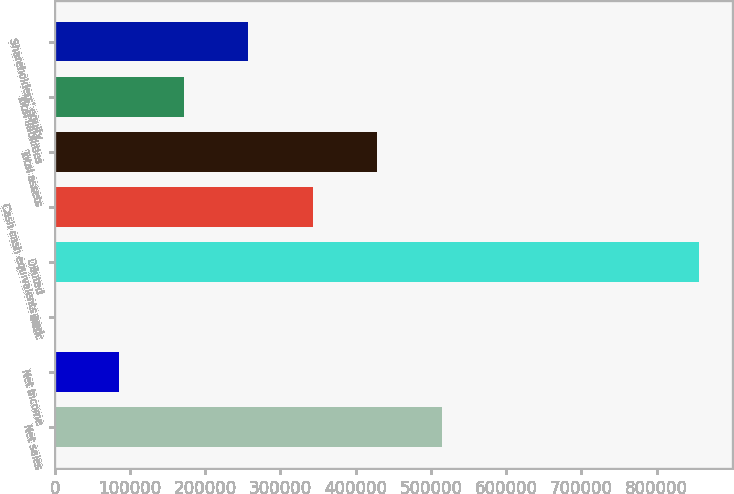Convert chart to OTSL. <chart><loc_0><loc_0><loc_500><loc_500><bar_chart><fcel>Net sales<fcel>Net income<fcel>Basic<fcel>Diluted<fcel>Cash cash equivalents and<fcel>Total assets<fcel>Total liabilities<fcel>Shareholders' equity<nl><fcel>514127<fcel>85689.3<fcel>1.64<fcel>856878<fcel>342752<fcel>428440<fcel>171377<fcel>257065<nl></chart> 